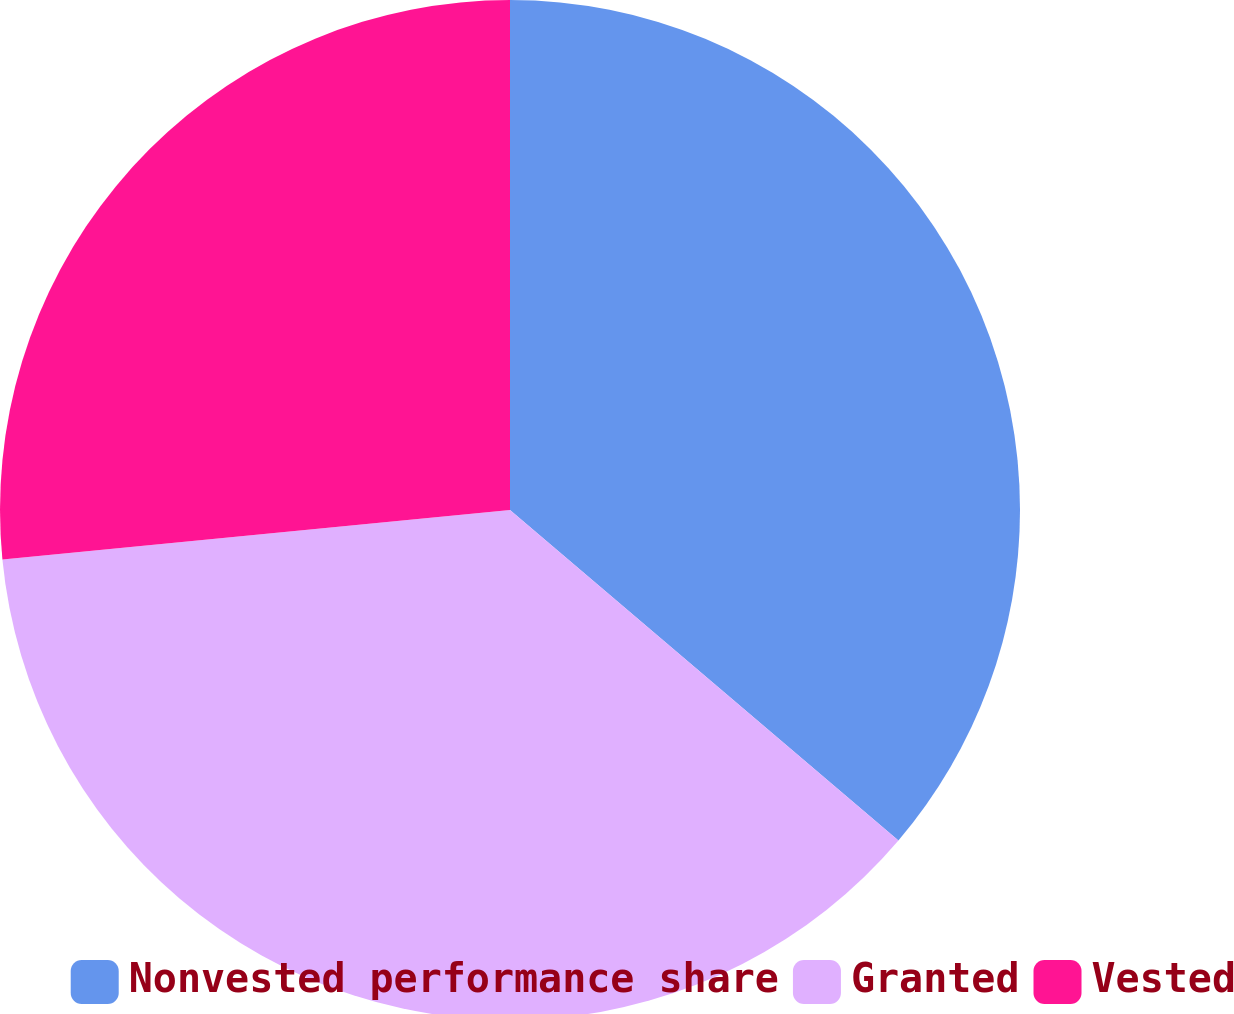Convert chart. <chart><loc_0><loc_0><loc_500><loc_500><pie_chart><fcel>Nonvested performance share<fcel>Granted<fcel>Vested<nl><fcel>36.22%<fcel>37.23%<fcel>26.55%<nl></chart> 